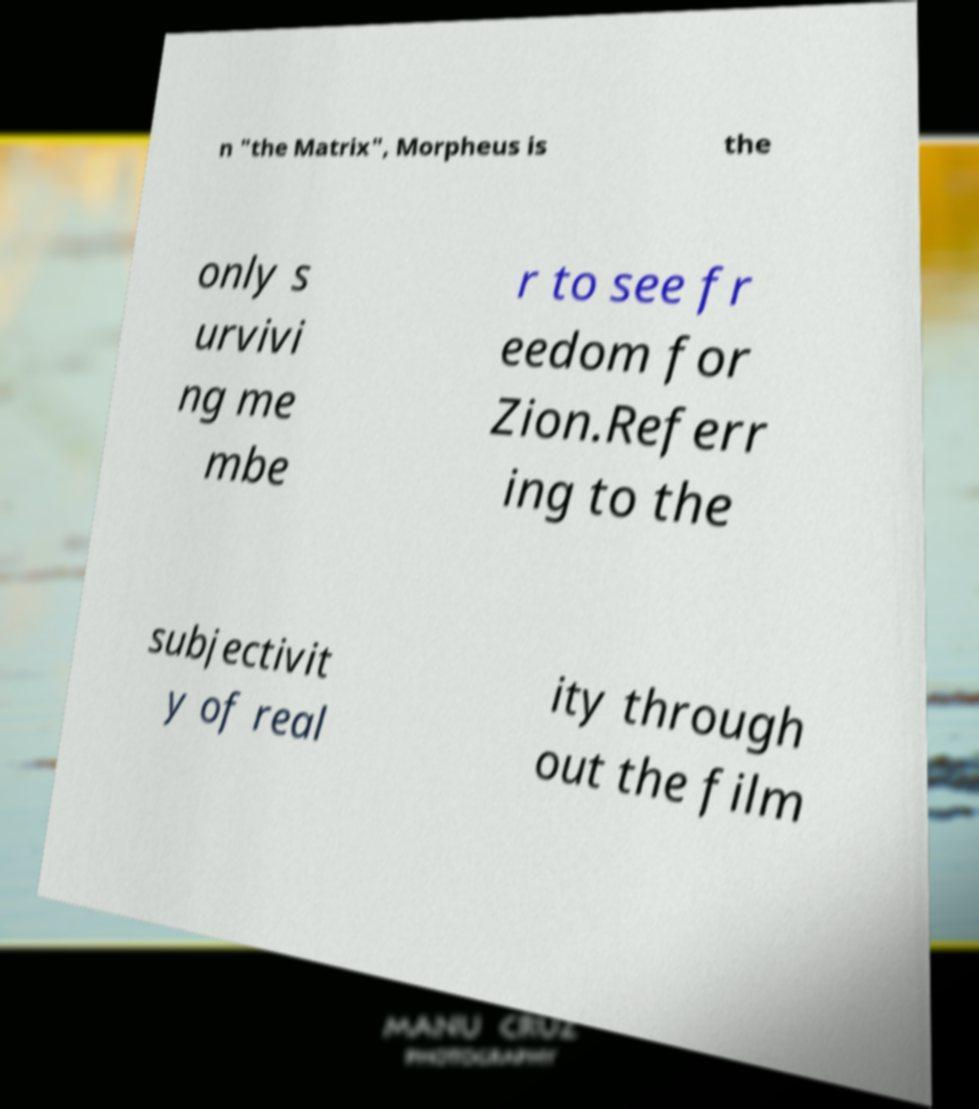For documentation purposes, I need the text within this image transcribed. Could you provide that? n "the Matrix", Morpheus is the only s urvivi ng me mbe r to see fr eedom for Zion.Referr ing to the subjectivit y of real ity through out the film 